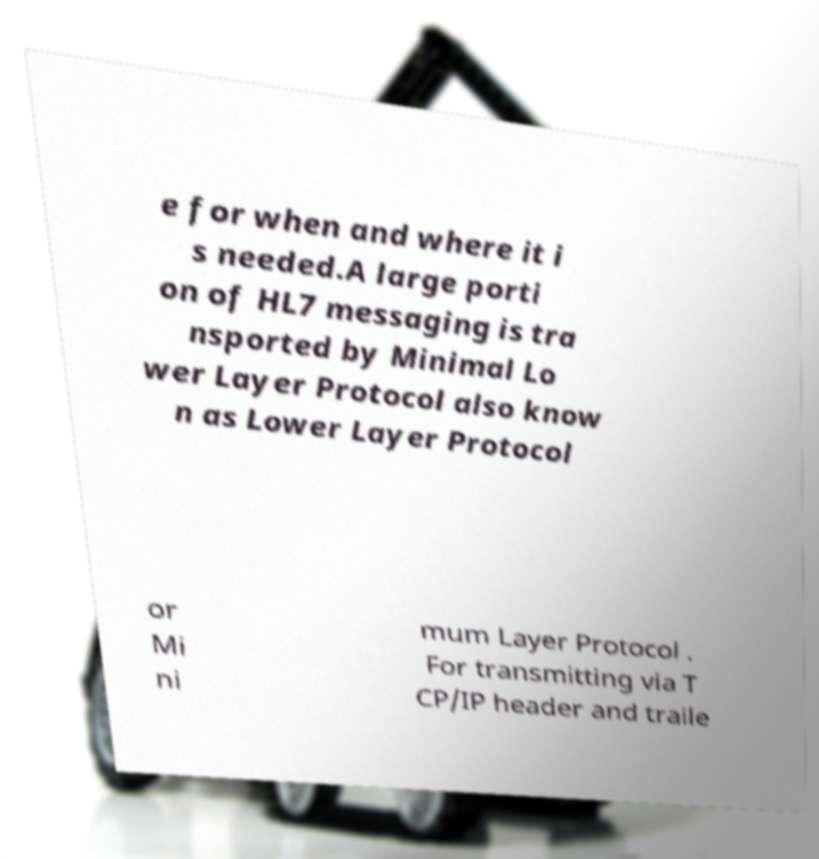I need the written content from this picture converted into text. Can you do that? e for when and where it i s needed.A large porti on of HL7 messaging is tra nsported by Minimal Lo wer Layer Protocol also know n as Lower Layer Protocol or Mi ni mum Layer Protocol . For transmitting via T CP/IP header and traile 